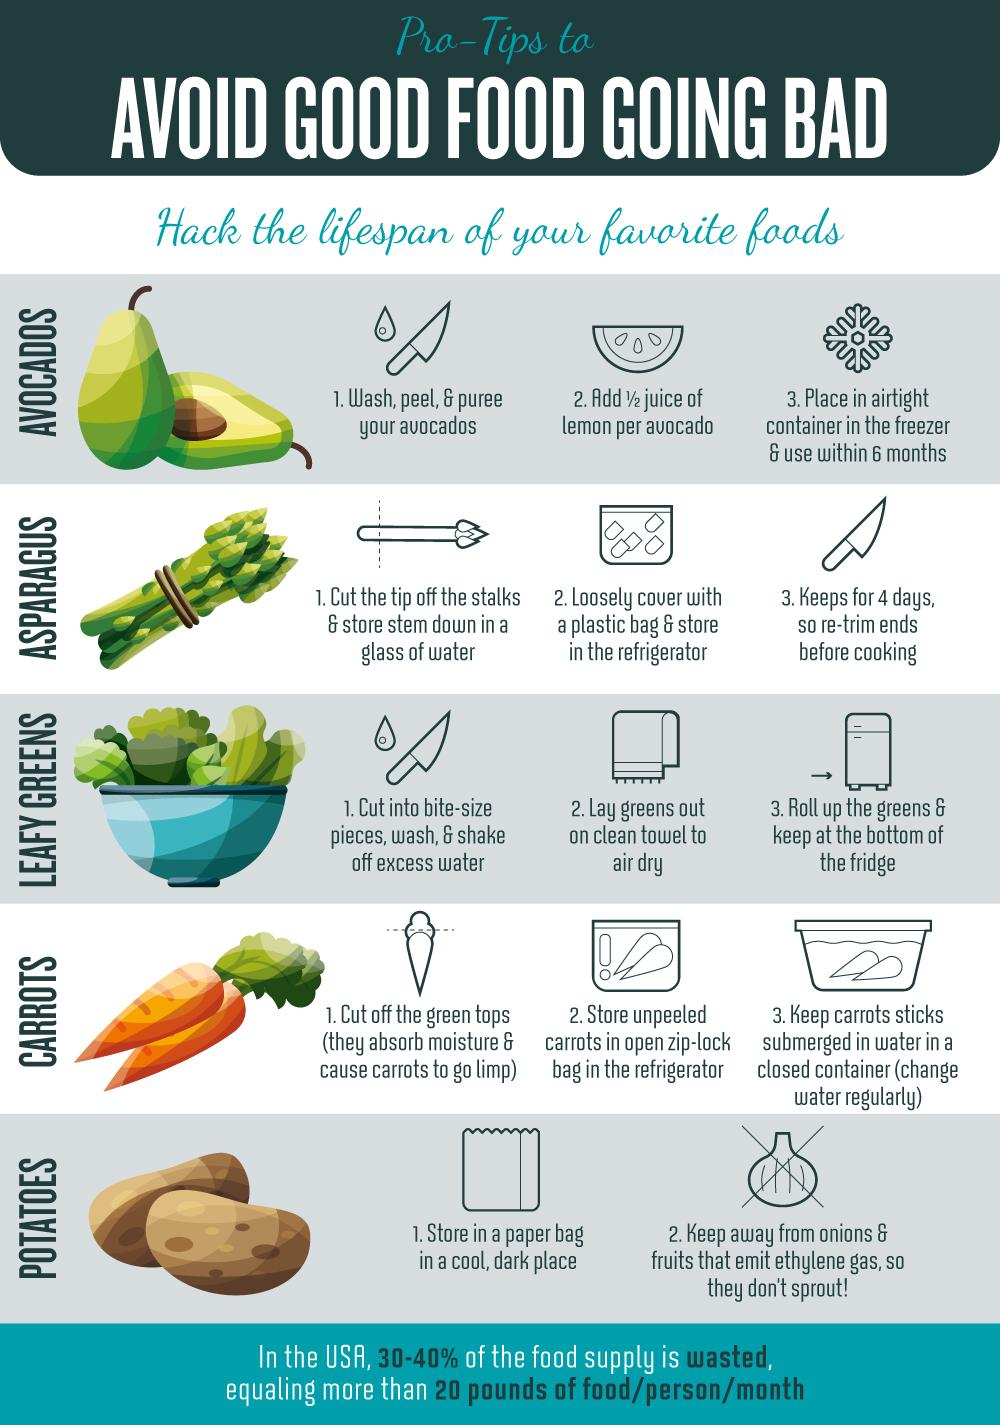Identify some key points in this picture. The removal of the green tops from carrots is recommended. Asparagus can be stored in a glass of water for a maximum of 4 days. Frozen avocados can be stored for a maximum of 6 months. It is recommended to cut leafy greens into pieces before storing them as this will help to prevent decay and prolong their freshness. It has been determined that avocados are in fact a fruit. 